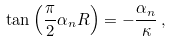Convert formula to latex. <formula><loc_0><loc_0><loc_500><loc_500>\tan \left ( \frac { \pi } { 2 } \alpha _ { n } R \right ) = - \frac { \alpha _ { n } } { \kappa } \, ,</formula> 